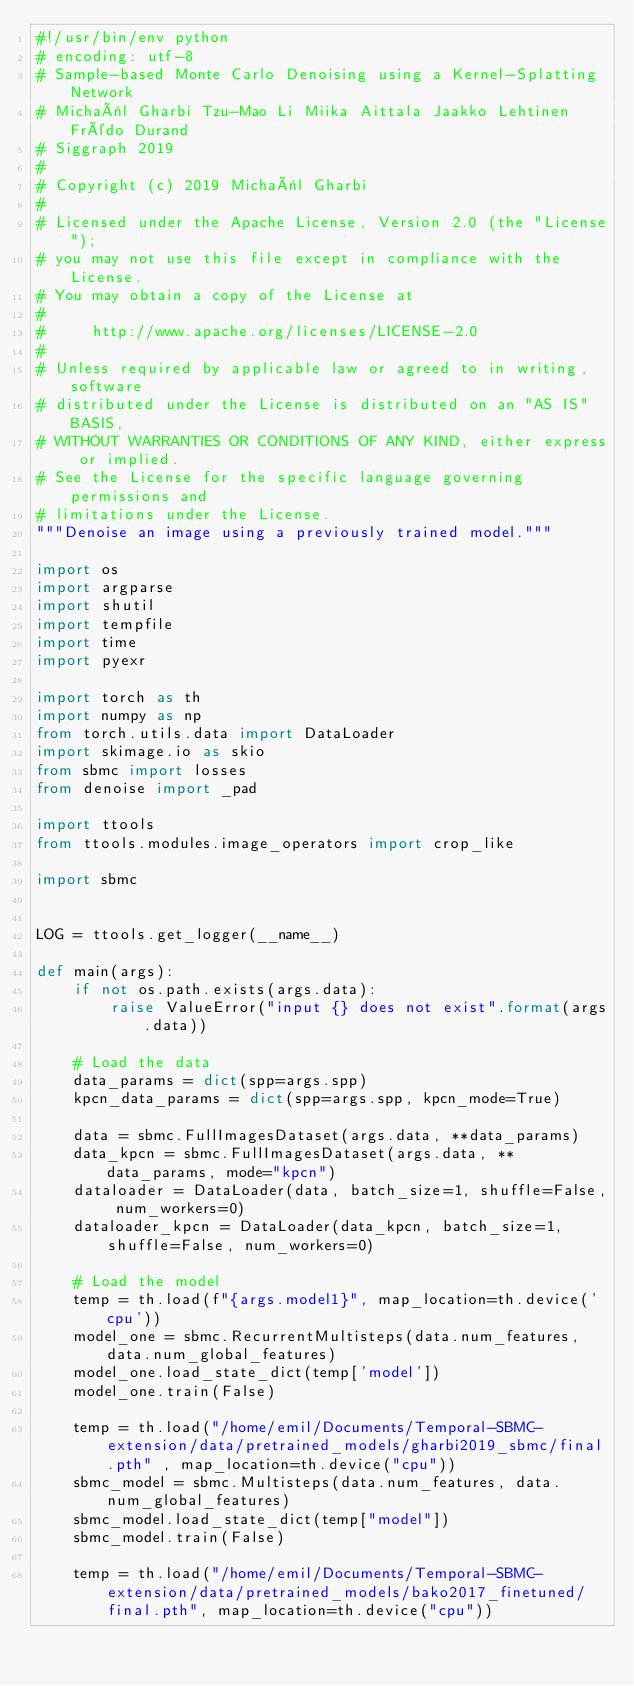<code> <loc_0><loc_0><loc_500><loc_500><_Python_>#!/usr/bin/env python
# encoding: utf-8
# Sample-based Monte Carlo Denoising using a Kernel-Splatting Network
# Michaël Gharbi Tzu-Mao Li Miika Aittala Jaakko Lehtinen Frédo Durand
# Siggraph 2019
#
# Copyright (c) 2019 Michaël Gharbi
#
# Licensed under the Apache License, Version 2.0 (the "License");
# you may not use this file except in compliance with the License.
# You may obtain a copy of the License at
#
#     http://www.apache.org/licenses/LICENSE-2.0
#
# Unless required by applicable law or agreed to in writing, software
# distributed under the License is distributed on an "AS IS" BASIS,
# WITHOUT WARRANTIES OR CONDITIONS OF ANY KIND, either express or implied.
# See the License for the specific language governing permissions and
# limitations under the License.
"""Denoise an image using a previously trained model."""

import os
import argparse
import shutil
import tempfile
import time
import pyexr

import torch as th
import numpy as np
from torch.utils.data import DataLoader
import skimage.io as skio
from sbmc import losses
from denoise import _pad

import ttools
from ttools.modules.image_operators import crop_like

import sbmc


LOG = ttools.get_logger(__name__)

def main(args):
    if not os.path.exists(args.data):
        raise ValueError("input {} does not exist".format(args.data))

    # Load the data
    data_params = dict(spp=args.spp)
    kpcn_data_params = dict(spp=args.spp, kpcn_mode=True)

    data = sbmc.FullImagesDataset(args.data, **data_params)
    data_kpcn = sbmc.FullImagesDataset(args.data, **data_params, mode="kpcn")
    dataloader = DataLoader(data, batch_size=1, shuffle=False, num_workers=0)
    dataloader_kpcn = DataLoader(data_kpcn, batch_size=1, shuffle=False, num_workers=0)

    # Load the model
    temp = th.load(f"{args.model1}", map_location=th.device('cpu'))
    model_one = sbmc.RecurrentMultisteps(data.num_features, data.num_global_features)
    model_one.load_state_dict(temp['model'])
    model_one.train(False)

    temp = th.load("/home/emil/Documents/Temporal-SBMC-extension/data/pretrained_models/gharbi2019_sbmc/final.pth" , map_location=th.device("cpu"))
    sbmc_model = sbmc.Multisteps(data.num_features, data.num_global_features)
    sbmc_model.load_state_dict(temp["model"])
    sbmc_model.train(False)
    
    temp = th.load("/home/emil/Documents/Temporal-SBMC-extension/data/pretrained_models/bako2017_finetuned/final.pth", map_location=th.device("cpu"))</code> 